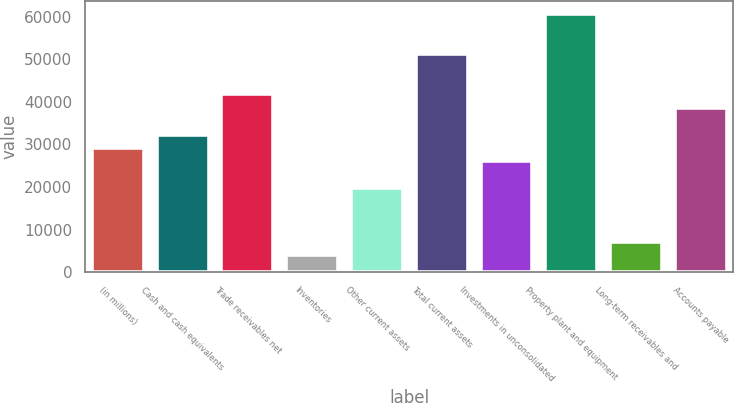<chart> <loc_0><loc_0><loc_500><loc_500><bar_chart><fcel>(in millions)<fcel>Cash and cash equivalents<fcel>Trade receivables net<fcel>Inventories<fcel>Other current assets<fcel>Total current assets<fcel>Investments in unconsolidated<fcel>Property plant and equipment<fcel>Long-term receivables and<fcel>Accounts payable<nl><fcel>29177.2<fcel>32337<fcel>41816.4<fcel>3898.8<fcel>19697.8<fcel>51295.8<fcel>26017.4<fcel>60775.2<fcel>7058.6<fcel>38656.6<nl></chart> 